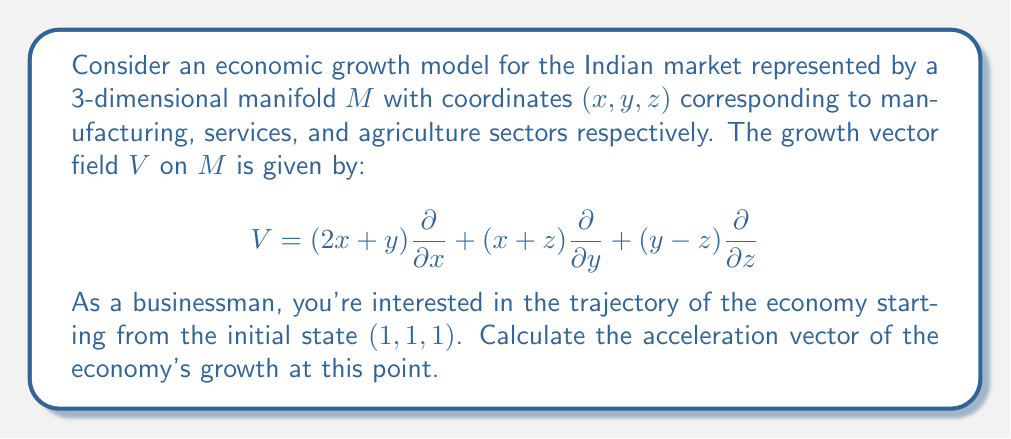Can you solve this math problem? To find the acceleration vector, we need to compute the covariant derivative of the vector field $V$ with respect to itself at the point $(1, 1, 1)$. This is given by:

$$\nabla_V V = (V \cdot \nabla)V$$

Step 1: Calculate the components of $V$ at $(1, 1, 1)$:
$V(1,1,1) = (3, 2, 0)$

Step 2: Compute the Jacobian matrix of $V$:
$$J = \begin{pmatrix}
2 & 1 & 0 \\
1 & 0 & 1 \\
0 & 1 & -1
\end{pmatrix}$$

Step 3: Multiply $V(1,1,1)$ by the Jacobian:
$$(V \cdot \nabla)V = (3, 2, 0) \begin{pmatrix}
2 & 1 & 0 \\
1 & 0 & 1 \\
0 & 1 & -1
\end{pmatrix}$$

Step 4: Perform the matrix multiplication:
$$(V \cdot \nabla)V = (3 \cdot 2 + 2 \cdot 1, 3 \cdot 1 + 2 \cdot 0, 3 \cdot 0 + 2 \cdot 1) = (8, 3, 2)$$

Therefore, the acceleration vector at $(1, 1, 1)$ is $(8, 3, 2)$.
Answer: $(8, 3, 2)$ 